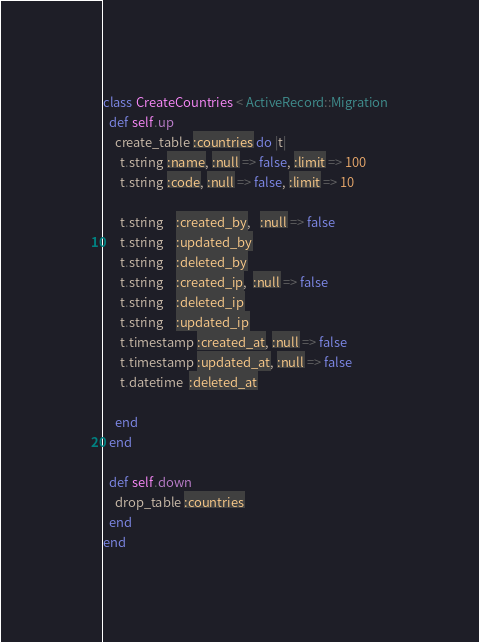<code> <loc_0><loc_0><loc_500><loc_500><_Ruby_>class CreateCountries < ActiveRecord::Migration
  def self.up
    create_table :countries do |t|
      t.string :name, :null => false, :limit => 100
      t.string :code, :null => false, :limit => 10

      t.string    :created_by,   :null => false
      t.string    :updated_by
      t.string    :deleted_by
      t.string    :created_ip,  :null => false
      t.string    :deleted_ip
      t.string    :updated_ip      
      t.timestamp :created_at, :null => false
      t.timestamp :updated_at, :null => false
      t.datetime  :deleted_at

    end
  end

  def self.down
    drop_table :countries
  end
end
</code> 